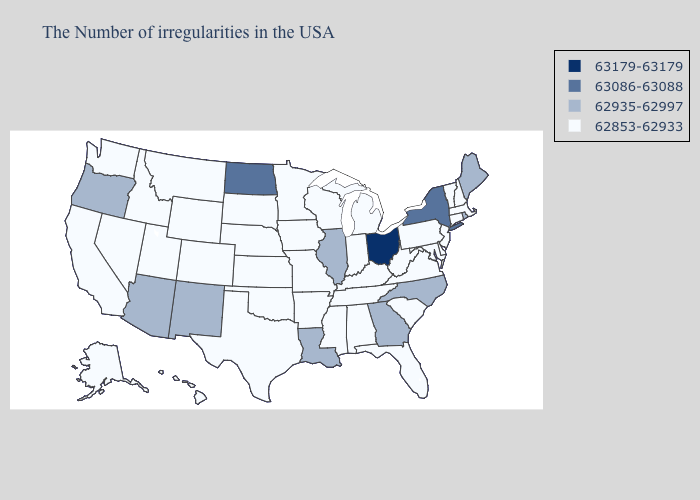What is the value of Kansas?
Answer briefly. 62853-62933. What is the value of Minnesota?
Give a very brief answer. 62853-62933. Name the states that have a value in the range 62935-62997?
Give a very brief answer. Maine, Rhode Island, North Carolina, Georgia, Illinois, Louisiana, New Mexico, Arizona, Oregon. Name the states that have a value in the range 62935-62997?
Quick response, please. Maine, Rhode Island, North Carolina, Georgia, Illinois, Louisiana, New Mexico, Arizona, Oregon. Does Kentucky have the lowest value in the USA?
Keep it brief. Yes. How many symbols are there in the legend?
Be succinct. 4. Which states have the lowest value in the USA?
Concise answer only. Massachusetts, New Hampshire, Vermont, Connecticut, New Jersey, Delaware, Maryland, Pennsylvania, Virginia, South Carolina, West Virginia, Florida, Michigan, Kentucky, Indiana, Alabama, Tennessee, Wisconsin, Mississippi, Missouri, Arkansas, Minnesota, Iowa, Kansas, Nebraska, Oklahoma, Texas, South Dakota, Wyoming, Colorado, Utah, Montana, Idaho, Nevada, California, Washington, Alaska, Hawaii. What is the value of South Carolina?
Be succinct. 62853-62933. How many symbols are there in the legend?
Concise answer only. 4. Does Maine have the highest value in the USA?
Short answer required. No. Does Ohio have the highest value in the USA?
Be succinct. Yes. Does Louisiana have the lowest value in the USA?
Give a very brief answer. No. Does Arizona have the highest value in the USA?
Answer briefly. No. What is the value of Mississippi?
Be succinct. 62853-62933. 